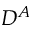Convert formula to latex. <formula><loc_0><loc_0><loc_500><loc_500>D ^ { A }</formula> 